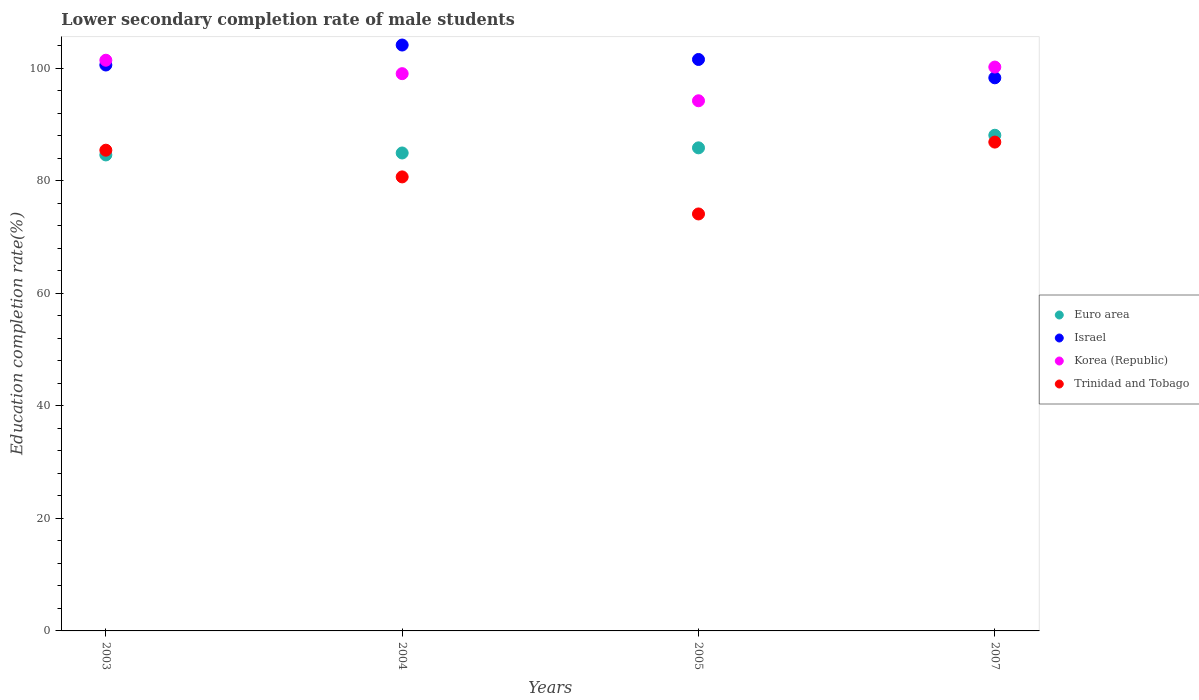How many different coloured dotlines are there?
Your answer should be very brief. 4. What is the lower secondary completion rate of male students in Israel in 2005?
Your answer should be very brief. 101.52. Across all years, what is the maximum lower secondary completion rate of male students in Trinidad and Tobago?
Your response must be concise. 86.84. Across all years, what is the minimum lower secondary completion rate of male students in Israel?
Ensure brevity in your answer.  98.26. In which year was the lower secondary completion rate of male students in Korea (Republic) maximum?
Your response must be concise. 2003. What is the total lower secondary completion rate of male students in Korea (Republic) in the graph?
Ensure brevity in your answer.  394.73. What is the difference between the lower secondary completion rate of male students in Trinidad and Tobago in 2003 and that in 2007?
Keep it short and to the point. -1.44. What is the difference between the lower secondary completion rate of male students in Israel in 2004 and the lower secondary completion rate of male students in Korea (Republic) in 2005?
Offer a very short reply. 9.91. What is the average lower secondary completion rate of male students in Korea (Republic) per year?
Ensure brevity in your answer.  98.68. In the year 2004, what is the difference between the lower secondary completion rate of male students in Korea (Republic) and lower secondary completion rate of male students in Trinidad and Tobago?
Your answer should be very brief. 18.34. In how many years, is the lower secondary completion rate of male students in Israel greater than 68 %?
Provide a short and direct response. 4. What is the ratio of the lower secondary completion rate of male students in Trinidad and Tobago in 2003 to that in 2005?
Make the answer very short. 1.15. What is the difference between the highest and the second highest lower secondary completion rate of male students in Korea (Republic)?
Your response must be concise. 1.21. What is the difference between the highest and the lowest lower secondary completion rate of male students in Israel?
Ensure brevity in your answer.  5.82. In how many years, is the lower secondary completion rate of male students in Trinidad and Tobago greater than the average lower secondary completion rate of male students in Trinidad and Tobago taken over all years?
Your answer should be compact. 2. Is the sum of the lower secondary completion rate of male students in Trinidad and Tobago in 2003 and 2004 greater than the maximum lower secondary completion rate of male students in Korea (Republic) across all years?
Offer a very short reply. Yes. Is the lower secondary completion rate of male students in Euro area strictly greater than the lower secondary completion rate of male students in Korea (Republic) over the years?
Your answer should be compact. No. Is the lower secondary completion rate of male students in Korea (Republic) strictly less than the lower secondary completion rate of male students in Trinidad and Tobago over the years?
Ensure brevity in your answer.  No. How many dotlines are there?
Give a very brief answer. 4. How many years are there in the graph?
Offer a very short reply. 4. Are the values on the major ticks of Y-axis written in scientific E-notation?
Your answer should be compact. No. Does the graph contain any zero values?
Provide a succinct answer. No. Does the graph contain grids?
Offer a very short reply. No. How are the legend labels stacked?
Provide a short and direct response. Vertical. What is the title of the graph?
Keep it short and to the point. Lower secondary completion rate of male students. What is the label or title of the Y-axis?
Provide a short and direct response. Education completion rate(%). What is the Education completion rate(%) of Euro area in 2003?
Your response must be concise. 84.56. What is the Education completion rate(%) in Israel in 2003?
Ensure brevity in your answer.  100.54. What is the Education completion rate(%) in Korea (Republic) in 2003?
Ensure brevity in your answer.  101.38. What is the Education completion rate(%) of Trinidad and Tobago in 2003?
Give a very brief answer. 85.4. What is the Education completion rate(%) of Euro area in 2004?
Your answer should be very brief. 84.91. What is the Education completion rate(%) of Israel in 2004?
Keep it short and to the point. 104.09. What is the Education completion rate(%) of Korea (Republic) in 2004?
Provide a short and direct response. 99. What is the Education completion rate(%) in Trinidad and Tobago in 2004?
Your response must be concise. 80.66. What is the Education completion rate(%) in Euro area in 2005?
Your answer should be compact. 85.82. What is the Education completion rate(%) in Israel in 2005?
Your answer should be compact. 101.52. What is the Education completion rate(%) in Korea (Republic) in 2005?
Keep it short and to the point. 94.18. What is the Education completion rate(%) in Trinidad and Tobago in 2005?
Offer a very short reply. 74.08. What is the Education completion rate(%) in Euro area in 2007?
Keep it short and to the point. 88.06. What is the Education completion rate(%) of Israel in 2007?
Offer a terse response. 98.26. What is the Education completion rate(%) in Korea (Republic) in 2007?
Your response must be concise. 100.17. What is the Education completion rate(%) in Trinidad and Tobago in 2007?
Your answer should be very brief. 86.84. Across all years, what is the maximum Education completion rate(%) of Euro area?
Your answer should be very brief. 88.06. Across all years, what is the maximum Education completion rate(%) in Israel?
Ensure brevity in your answer.  104.09. Across all years, what is the maximum Education completion rate(%) in Korea (Republic)?
Ensure brevity in your answer.  101.38. Across all years, what is the maximum Education completion rate(%) of Trinidad and Tobago?
Give a very brief answer. 86.84. Across all years, what is the minimum Education completion rate(%) of Euro area?
Offer a terse response. 84.56. Across all years, what is the minimum Education completion rate(%) of Israel?
Provide a succinct answer. 98.26. Across all years, what is the minimum Education completion rate(%) in Korea (Republic)?
Provide a succinct answer. 94.18. Across all years, what is the minimum Education completion rate(%) in Trinidad and Tobago?
Keep it short and to the point. 74.08. What is the total Education completion rate(%) in Euro area in the graph?
Offer a terse response. 343.35. What is the total Education completion rate(%) of Israel in the graph?
Your answer should be compact. 404.4. What is the total Education completion rate(%) in Korea (Republic) in the graph?
Your response must be concise. 394.73. What is the total Education completion rate(%) of Trinidad and Tobago in the graph?
Your response must be concise. 326.98. What is the difference between the Education completion rate(%) of Euro area in 2003 and that in 2004?
Ensure brevity in your answer.  -0.35. What is the difference between the Education completion rate(%) in Israel in 2003 and that in 2004?
Offer a terse response. -3.55. What is the difference between the Education completion rate(%) in Korea (Republic) in 2003 and that in 2004?
Provide a succinct answer. 2.39. What is the difference between the Education completion rate(%) of Trinidad and Tobago in 2003 and that in 2004?
Ensure brevity in your answer.  4.74. What is the difference between the Education completion rate(%) of Euro area in 2003 and that in 2005?
Keep it short and to the point. -1.26. What is the difference between the Education completion rate(%) in Israel in 2003 and that in 2005?
Offer a very short reply. -0.98. What is the difference between the Education completion rate(%) in Korea (Republic) in 2003 and that in 2005?
Offer a very short reply. 7.2. What is the difference between the Education completion rate(%) in Trinidad and Tobago in 2003 and that in 2005?
Ensure brevity in your answer.  11.32. What is the difference between the Education completion rate(%) of Euro area in 2003 and that in 2007?
Ensure brevity in your answer.  -3.49. What is the difference between the Education completion rate(%) in Israel in 2003 and that in 2007?
Your answer should be very brief. 2.27. What is the difference between the Education completion rate(%) in Korea (Republic) in 2003 and that in 2007?
Offer a terse response. 1.21. What is the difference between the Education completion rate(%) of Trinidad and Tobago in 2003 and that in 2007?
Ensure brevity in your answer.  -1.44. What is the difference between the Education completion rate(%) of Euro area in 2004 and that in 2005?
Your response must be concise. -0.91. What is the difference between the Education completion rate(%) of Israel in 2004 and that in 2005?
Ensure brevity in your answer.  2.57. What is the difference between the Education completion rate(%) in Korea (Republic) in 2004 and that in 2005?
Keep it short and to the point. 4.82. What is the difference between the Education completion rate(%) in Trinidad and Tobago in 2004 and that in 2005?
Give a very brief answer. 6.58. What is the difference between the Education completion rate(%) of Euro area in 2004 and that in 2007?
Your response must be concise. -3.15. What is the difference between the Education completion rate(%) in Israel in 2004 and that in 2007?
Make the answer very short. 5.82. What is the difference between the Education completion rate(%) of Korea (Republic) in 2004 and that in 2007?
Give a very brief answer. -1.17. What is the difference between the Education completion rate(%) of Trinidad and Tobago in 2004 and that in 2007?
Offer a very short reply. -6.18. What is the difference between the Education completion rate(%) in Euro area in 2005 and that in 2007?
Your response must be concise. -2.24. What is the difference between the Education completion rate(%) of Israel in 2005 and that in 2007?
Your response must be concise. 3.26. What is the difference between the Education completion rate(%) of Korea (Republic) in 2005 and that in 2007?
Keep it short and to the point. -5.99. What is the difference between the Education completion rate(%) of Trinidad and Tobago in 2005 and that in 2007?
Your response must be concise. -12.76. What is the difference between the Education completion rate(%) of Euro area in 2003 and the Education completion rate(%) of Israel in 2004?
Your answer should be very brief. -19.52. What is the difference between the Education completion rate(%) of Euro area in 2003 and the Education completion rate(%) of Korea (Republic) in 2004?
Offer a terse response. -14.44. What is the difference between the Education completion rate(%) of Euro area in 2003 and the Education completion rate(%) of Trinidad and Tobago in 2004?
Your response must be concise. 3.9. What is the difference between the Education completion rate(%) in Israel in 2003 and the Education completion rate(%) in Korea (Republic) in 2004?
Give a very brief answer. 1.54. What is the difference between the Education completion rate(%) of Israel in 2003 and the Education completion rate(%) of Trinidad and Tobago in 2004?
Make the answer very short. 19.88. What is the difference between the Education completion rate(%) of Korea (Republic) in 2003 and the Education completion rate(%) of Trinidad and Tobago in 2004?
Provide a succinct answer. 20.73. What is the difference between the Education completion rate(%) in Euro area in 2003 and the Education completion rate(%) in Israel in 2005?
Your answer should be very brief. -16.96. What is the difference between the Education completion rate(%) in Euro area in 2003 and the Education completion rate(%) in Korea (Republic) in 2005?
Provide a succinct answer. -9.62. What is the difference between the Education completion rate(%) in Euro area in 2003 and the Education completion rate(%) in Trinidad and Tobago in 2005?
Ensure brevity in your answer.  10.48. What is the difference between the Education completion rate(%) of Israel in 2003 and the Education completion rate(%) of Korea (Republic) in 2005?
Give a very brief answer. 6.35. What is the difference between the Education completion rate(%) in Israel in 2003 and the Education completion rate(%) in Trinidad and Tobago in 2005?
Keep it short and to the point. 26.46. What is the difference between the Education completion rate(%) in Korea (Republic) in 2003 and the Education completion rate(%) in Trinidad and Tobago in 2005?
Your response must be concise. 27.31. What is the difference between the Education completion rate(%) of Euro area in 2003 and the Education completion rate(%) of Israel in 2007?
Provide a short and direct response. -13.7. What is the difference between the Education completion rate(%) of Euro area in 2003 and the Education completion rate(%) of Korea (Republic) in 2007?
Provide a succinct answer. -15.61. What is the difference between the Education completion rate(%) of Euro area in 2003 and the Education completion rate(%) of Trinidad and Tobago in 2007?
Make the answer very short. -2.28. What is the difference between the Education completion rate(%) in Israel in 2003 and the Education completion rate(%) in Korea (Republic) in 2007?
Your answer should be very brief. 0.36. What is the difference between the Education completion rate(%) of Israel in 2003 and the Education completion rate(%) of Trinidad and Tobago in 2007?
Your response must be concise. 13.69. What is the difference between the Education completion rate(%) of Korea (Republic) in 2003 and the Education completion rate(%) of Trinidad and Tobago in 2007?
Provide a short and direct response. 14.54. What is the difference between the Education completion rate(%) of Euro area in 2004 and the Education completion rate(%) of Israel in 2005?
Your response must be concise. -16.61. What is the difference between the Education completion rate(%) in Euro area in 2004 and the Education completion rate(%) in Korea (Republic) in 2005?
Keep it short and to the point. -9.27. What is the difference between the Education completion rate(%) in Euro area in 2004 and the Education completion rate(%) in Trinidad and Tobago in 2005?
Your answer should be compact. 10.83. What is the difference between the Education completion rate(%) of Israel in 2004 and the Education completion rate(%) of Korea (Republic) in 2005?
Your answer should be compact. 9.91. What is the difference between the Education completion rate(%) in Israel in 2004 and the Education completion rate(%) in Trinidad and Tobago in 2005?
Keep it short and to the point. 30.01. What is the difference between the Education completion rate(%) of Korea (Republic) in 2004 and the Education completion rate(%) of Trinidad and Tobago in 2005?
Your response must be concise. 24.92. What is the difference between the Education completion rate(%) in Euro area in 2004 and the Education completion rate(%) in Israel in 2007?
Provide a succinct answer. -13.35. What is the difference between the Education completion rate(%) of Euro area in 2004 and the Education completion rate(%) of Korea (Republic) in 2007?
Your response must be concise. -15.26. What is the difference between the Education completion rate(%) of Euro area in 2004 and the Education completion rate(%) of Trinidad and Tobago in 2007?
Provide a succinct answer. -1.93. What is the difference between the Education completion rate(%) of Israel in 2004 and the Education completion rate(%) of Korea (Republic) in 2007?
Make the answer very short. 3.92. What is the difference between the Education completion rate(%) of Israel in 2004 and the Education completion rate(%) of Trinidad and Tobago in 2007?
Offer a terse response. 17.25. What is the difference between the Education completion rate(%) of Korea (Republic) in 2004 and the Education completion rate(%) of Trinidad and Tobago in 2007?
Your answer should be very brief. 12.16. What is the difference between the Education completion rate(%) in Euro area in 2005 and the Education completion rate(%) in Israel in 2007?
Keep it short and to the point. -12.44. What is the difference between the Education completion rate(%) of Euro area in 2005 and the Education completion rate(%) of Korea (Republic) in 2007?
Offer a terse response. -14.35. What is the difference between the Education completion rate(%) in Euro area in 2005 and the Education completion rate(%) in Trinidad and Tobago in 2007?
Give a very brief answer. -1.02. What is the difference between the Education completion rate(%) in Israel in 2005 and the Education completion rate(%) in Korea (Republic) in 2007?
Your response must be concise. 1.35. What is the difference between the Education completion rate(%) in Israel in 2005 and the Education completion rate(%) in Trinidad and Tobago in 2007?
Ensure brevity in your answer.  14.68. What is the difference between the Education completion rate(%) in Korea (Republic) in 2005 and the Education completion rate(%) in Trinidad and Tobago in 2007?
Your answer should be very brief. 7.34. What is the average Education completion rate(%) of Euro area per year?
Keep it short and to the point. 85.84. What is the average Education completion rate(%) of Israel per year?
Provide a short and direct response. 101.1. What is the average Education completion rate(%) of Korea (Republic) per year?
Your answer should be compact. 98.68. What is the average Education completion rate(%) in Trinidad and Tobago per year?
Your answer should be compact. 81.74. In the year 2003, what is the difference between the Education completion rate(%) in Euro area and Education completion rate(%) in Israel?
Offer a terse response. -15.97. In the year 2003, what is the difference between the Education completion rate(%) of Euro area and Education completion rate(%) of Korea (Republic)?
Your response must be concise. -16.82. In the year 2003, what is the difference between the Education completion rate(%) of Euro area and Education completion rate(%) of Trinidad and Tobago?
Make the answer very short. -0.84. In the year 2003, what is the difference between the Education completion rate(%) of Israel and Education completion rate(%) of Korea (Republic)?
Ensure brevity in your answer.  -0.85. In the year 2003, what is the difference between the Education completion rate(%) in Israel and Education completion rate(%) in Trinidad and Tobago?
Offer a very short reply. 15.13. In the year 2003, what is the difference between the Education completion rate(%) in Korea (Republic) and Education completion rate(%) in Trinidad and Tobago?
Offer a very short reply. 15.98. In the year 2004, what is the difference between the Education completion rate(%) in Euro area and Education completion rate(%) in Israel?
Ensure brevity in your answer.  -19.18. In the year 2004, what is the difference between the Education completion rate(%) of Euro area and Education completion rate(%) of Korea (Republic)?
Keep it short and to the point. -14.09. In the year 2004, what is the difference between the Education completion rate(%) in Euro area and Education completion rate(%) in Trinidad and Tobago?
Offer a terse response. 4.25. In the year 2004, what is the difference between the Education completion rate(%) of Israel and Education completion rate(%) of Korea (Republic)?
Offer a very short reply. 5.09. In the year 2004, what is the difference between the Education completion rate(%) of Israel and Education completion rate(%) of Trinidad and Tobago?
Make the answer very short. 23.43. In the year 2004, what is the difference between the Education completion rate(%) in Korea (Republic) and Education completion rate(%) in Trinidad and Tobago?
Provide a succinct answer. 18.34. In the year 2005, what is the difference between the Education completion rate(%) of Euro area and Education completion rate(%) of Israel?
Offer a terse response. -15.7. In the year 2005, what is the difference between the Education completion rate(%) in Euro area and Education completion rate(%) in Korea (Republic)?
Offer a terse response. -8.36. In the year 2005, what is the difference between the Education completion rate(%) of Euro area and Education completion rate(%) of Trinidad and Tobago?
Keep it short and to the point. 11.74. In the year 2005, what is the difference between the Education completion rate(%) of Israel and Education completion rate(%) of Korea (Republic)?
Make the answer very short. 7.34. In the year 2005, what is the difference between the Education completion rate(%) in Israel and Education completion rate(%) in Trinidad and Tobago?
Your answer should be very brief. 27.44. In the year 2005, what is the difference between the Education completion rate(%) in Korea (Republic) and Education completion rate(%) in Trinidad and Tobago?
Keep it short and to the point. 20.1. In the year 2007, what is the difference between the Education completion rate(%) in Euro area and Education completion rate(%) in Israel?
Provide a succinct answer. -10.21. In the year 2007, what is the difference between the Education completion rate(%) in Euro area and Education completion rate(%) in Korea (Republic)?
Give a very brief answer. -12.12. In the year 2007, what is the difference between the Education completion rate(%) in Euro area and Education completion rate(%) in Trinidad and Tobago?
Offer a terse response. 1.21. In the year 2007, what is the difference between the Education completion rate(%) in Israel and Education completion rate(%) in Korea (Republic)?
Provide a succinct answer. -1.91. In the year 2007, what is the difference between the Education completion rate(%) of Israel and Education completion rate(%) of Trinidad and Tobago?
Provide a short and direct response. 11.42. In the year 2007, what is the difference between the Education completion rate(%) of Korea (Republic) and Education completion rate(%) of Trinidad and Tobago?
Your response must be concise. 13.33. What is the ratio of the Education completion rate(%) of Israel in 2003 to that in 2004?
Make the answer very short. 0.97. What is the ratio of the Education completion rate(%) in Korea (Republic) in 2003 to that in 2004?
Provide a succinct answer. 1.02. What is the ratio of the Education completion rate(%) in Trinidad and Tobago in 2003 to that in 2004?
Offer a very short reply. 1.06. What is the ratio of the Education completion rate(%) in Euro area in 2003 to that in 2005?
Offer a terse response. 0.99. What is the ratio of the Education completion rate(%) of Israel in 2003 to that in 2005?
Offer a terse response. 0.99. What is the ratio of the Education completion rate(%) in Korea (Republic) in 2003 to that in 2005?
Offer a terse response. 1.08. What is the ratio of the Education completion rate(%) of Trinidad and Tobago in 2003 to that in 2005?
Provide a succinct answer. 1.15. What is the ratio of the Education completion rate(%) in Euro area in 2003 to that in 2007?
Ensure brevity in your answer.  0.96. What is the ratio of the Education completion rate(%) in Israel in 2003 to that in 2007?
Keep it short and to the point. 1.02. What is the ratio of the Education completion rate(%) of Korea (Republic) in 2003 to that in 2007?
Ensure brevity in your answer.  1.01. What is the ratio of the Education completion rate(%) of Trinidad and Tobago in 2003 to that in 2007?
Provide a succinct answer. 0.98. What is the ratio of the Education completion rate(%) in Euro area in 2004 to that in 2005?
Give a very brief answer. 0.99. What is the ratio of the Education completion rate(%) in Israel in 2004 to that in 2005?
Make the answer very short. 1.03. What is the ratio of the Education completion rate(%) of Korea (Republic) in 2004 to that in 2005?
Keep it short and to the point. 1.05. What is the ratio of the Education completion rate(%) of Trinidad and Tobago in 2004 to that in 2005?
Make the answer very short. 1.09. What is the ratio of the Education completion rate(%) in Euro area in 2004 to that in 2007?
Your response must be concise. 0.96. What is the ratio of the Education completion rate(%) of Israel in 2004 to that in 2007?
Give a very brief answer. 1.06. What is the ratio of the Education completion rate(%) of Korea (Republic) in 2004 to that in 2007?
Ensure brevity in your answer.  0.99. What is the ratio of the Education completion rate(%) in Trinidad and Tobago in 2004 to that in 2007?
Ensure brevity in your answer.  0.93. What is the ratio of the Education completion rate(%) in Euro area in 2005 to that in 2007?
Provide a succinct answer. 0.97. What is the ratio of the Education completion rate(%) of Israel in 2005 to that in 2007?
Provide a short and direct response. 1.03. What is the ratio of the Education completion rate(%) of Korea (Republic) in 2005 to that in 2007?
Ensure brevity in your answer.  0.94. What is the ratio of the Education completion rate(%) in Trinidad and Tobago in 2005 to that in 2007?
Keep it short and to the point. 0.85. What is the difference between the highest and the second highest Education completion rate(%) in Euro area?
Your answer should be very brief. 2.24. What is the difference between the highest and the second highest Education completion rate(%) in Israel?
Give a very brief answer. 2.57. What is the difference between the highest and the second highest Education completion rate(%) of Korea (Republic)?
Offer a terse response. 1.21. What is the difference between the highest and the second highest Education completion rate(%) of Trinidad and Tobago?
Provide a short and direct response. 1.44. What is the difference between the highest and the lowest Education completion rate(%) in Euro area?
Your answer should be compact. 3.49. What is the difference between the highest and the lowest Education completion rate(%) in Israel?
Ensure brevity in your answer.  5.82. What is the difference between the highest and the lowest Education completion rate(%) of Korea (Republic)?
Your answer should be very brief. 7.2. What is the difference between the highest and the lowest Education completion rate(%) in Trinidad and Tobago?
Make the answer very short. 12.76. 